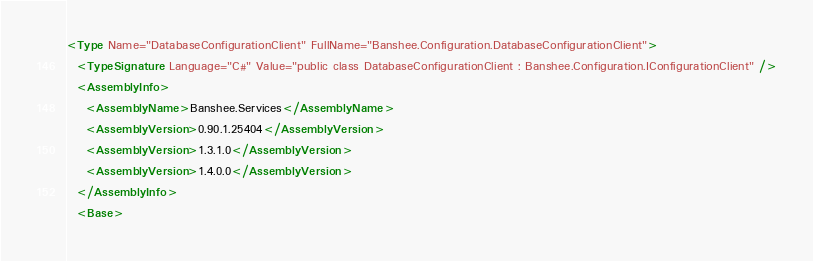Convert code to text. <code><loc_0><loc_0><loc_500><loc_500><_XML_><Type Name="DatabaseConfigurationClient" FullName="Banshee.Configuration.DatabaseConfigurationClient">
  <TypeSignature Language="C#" Value="public class DatabaseConfigurationClient : Banshee.Configuration.IConfigurationClient" />
  <AssemblyInfo>
    <AssemblyName>Banshee.Services</AssemblyName>
    <AssemblyVersion>0.90.1.25404</AssemblyVersion>
    <AssemblyVersion>1.3.1.0</AssemblyVersion>
    <AssemblyVersion>1.4.0.0</AssemblyVersion>
  </AssemblyInfo>
  <Base></code> 